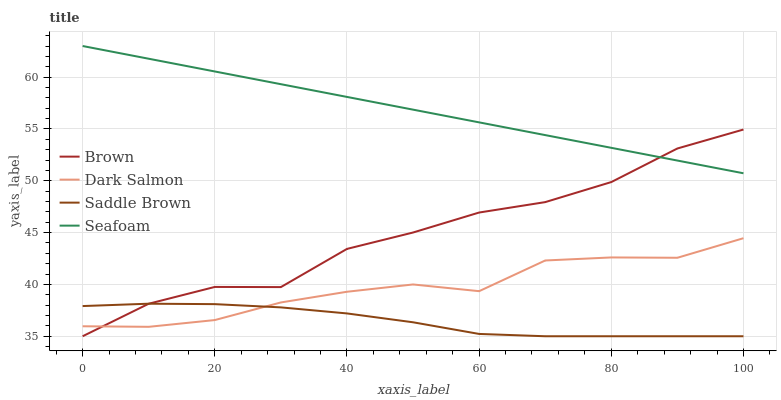Does Saddle Brown have the minimum area under the curve?
Answer yes or no. Yes. Does Seafoam have the maximum area under the curve?
Answer yes or no. Yes. Does Dark Salmon have the minimum area under the curve?
Answer yes or no. No. Does Dark Salmon have the maximum area under the curve?
Answer yes or no. No. Is Seafoam the smoothest?
Answer yes or no. Yes. Is Brown the roughest?
Answer yes or no. Yes. Is Dark Salmon the smoothest?
Answer yes or no. No. Is Dark Salmon the roughest?
Answer yes or no. No. Does Dark Salmon have the lowest value?
Answer yes or no. No. Does Seafoam have the highest value?
Answer yes or no. Yes. Does Dark Salmon have the highest value?
Answer yes or no. No. Is Dark Salmon less than Seafoam?
Answer yes or no. Yes. Is Seafoam greater than Dark Salmon?
Answer yes or no. Yes. Does Dark Salmon intersect Brown?
Answer yes or no. Yes. Is Dark Salmon less than Brown?
Answer yes or no. No. Is Dark Salmon greater than Brown?
Answer yes or no. No. Does Dark Salmon intersect Seafoam?
Answer yes or no. No. 